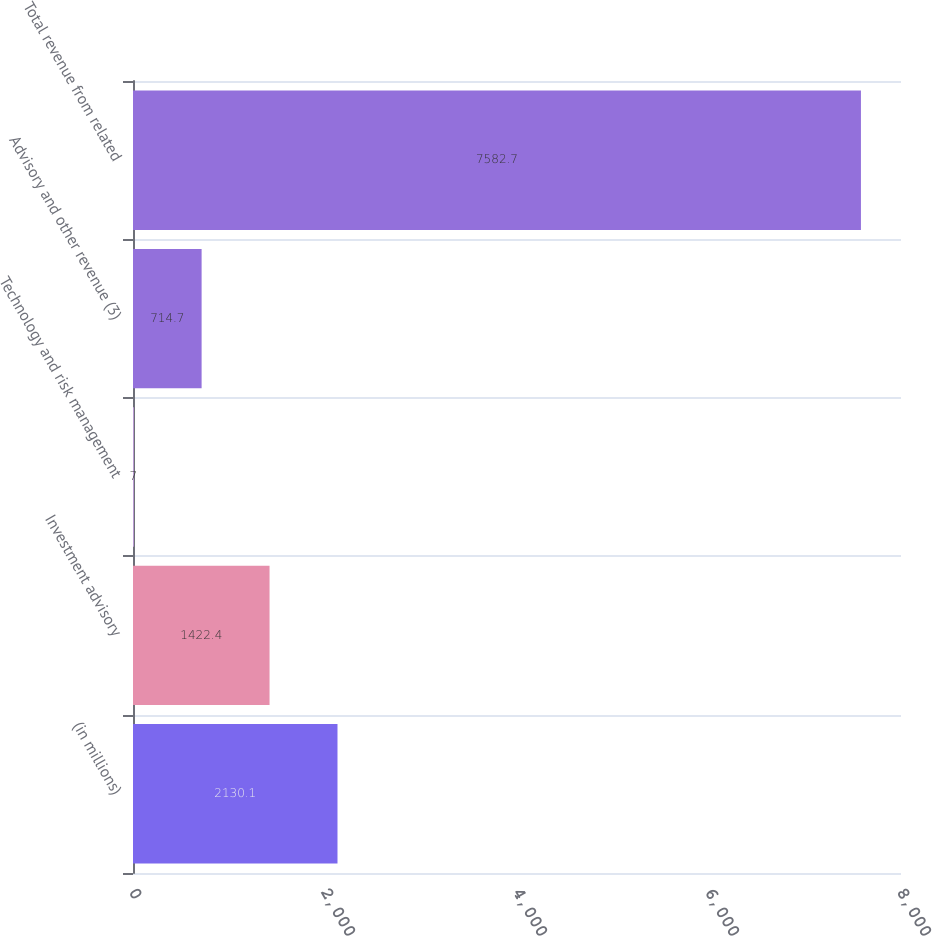Convert chart. <chart><loc_0><loc_0><loc_500><loc_500><bar_chart><fcel>(in millions)<fcel>Investment advisory<fcel>Technology and risk management<fcel>Advisory and other revenue (3)<fcel>Total revenue from related<nl><fcel>2130.1<fcel>1422.4<fcel>7<fcel>714.7<fcel>7582.7<nl></chart> 